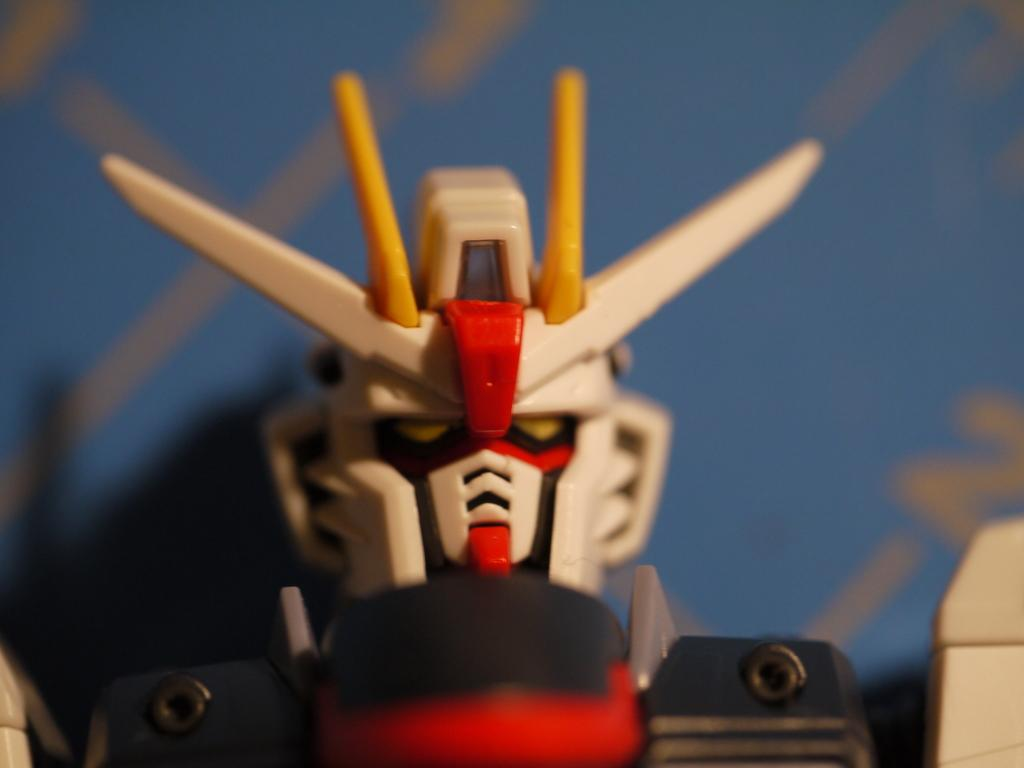What object can be seen in the image? There is a toy in the image. Can you describe the background of the image? The background of the image is blurred. How many steps does the baby take in the image? There is no baby present in the image, so it is not possible to determine how many steps the baby takes. What type of hair can be seen on the toy in the image? The toy in the image does not have hair, as it is not a human or an animal with hair. 